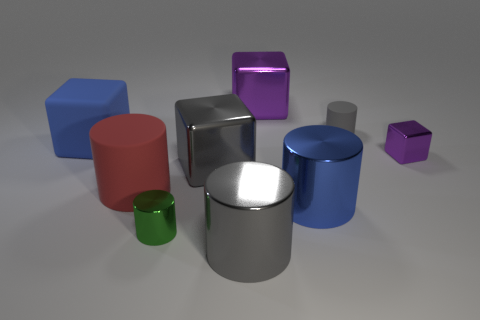Can you explain the lighting setup based on the reflections and shadows seen in the image? The lighting in the scene suggests a setup with at least one bright light source, possibly positioned above the objects, creating distinct, but soft-edged shadows beneath each object. The reflections on the glossy and metallic surfaces indicate the presence of a high dynamic range environment, contributing to realistic specular highlights and providing depth to the scene. 